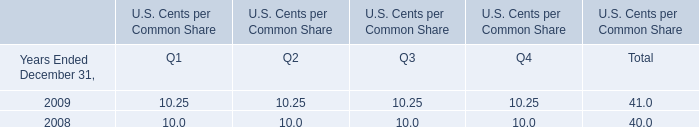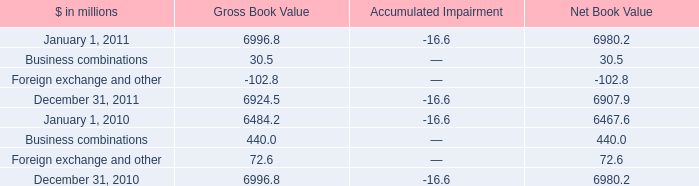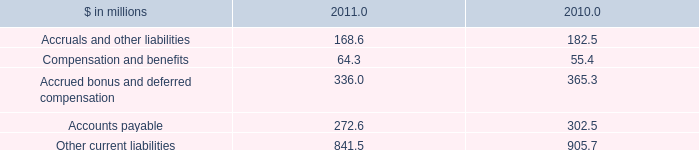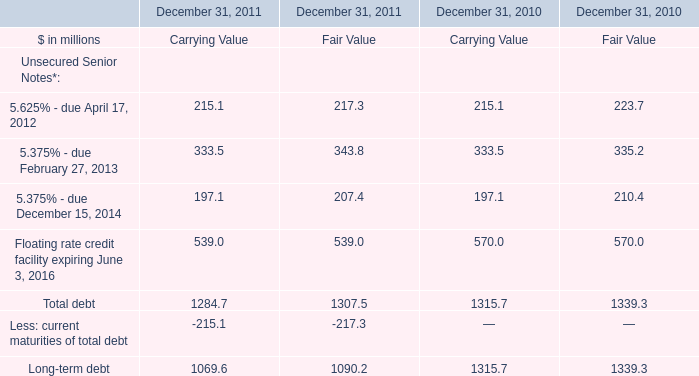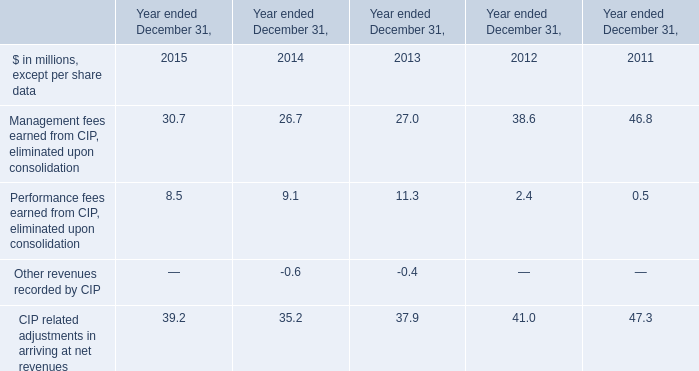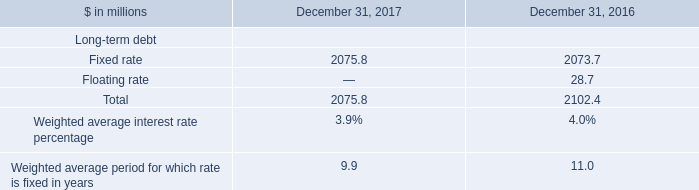What is the total amount of Fixed rate of December 31, 2016, and December 31, 2010 of Gross Book Value ? 
Computations: (2073.7 + 6996.8)
Answer: 9070.5. 